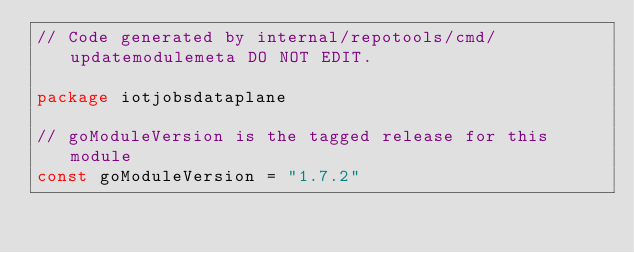Convert code to text. <code><loc_0><loc_0><loc_500><loc_500><_Go_>// Code generated by internal/repotools/cmd/updatemodulemeta DO NOT EDIT.

package iotjobsdataplane

// goModuleVersion is the tagged release for this module
const goModuleVersion = "1.7.2"
</code> 